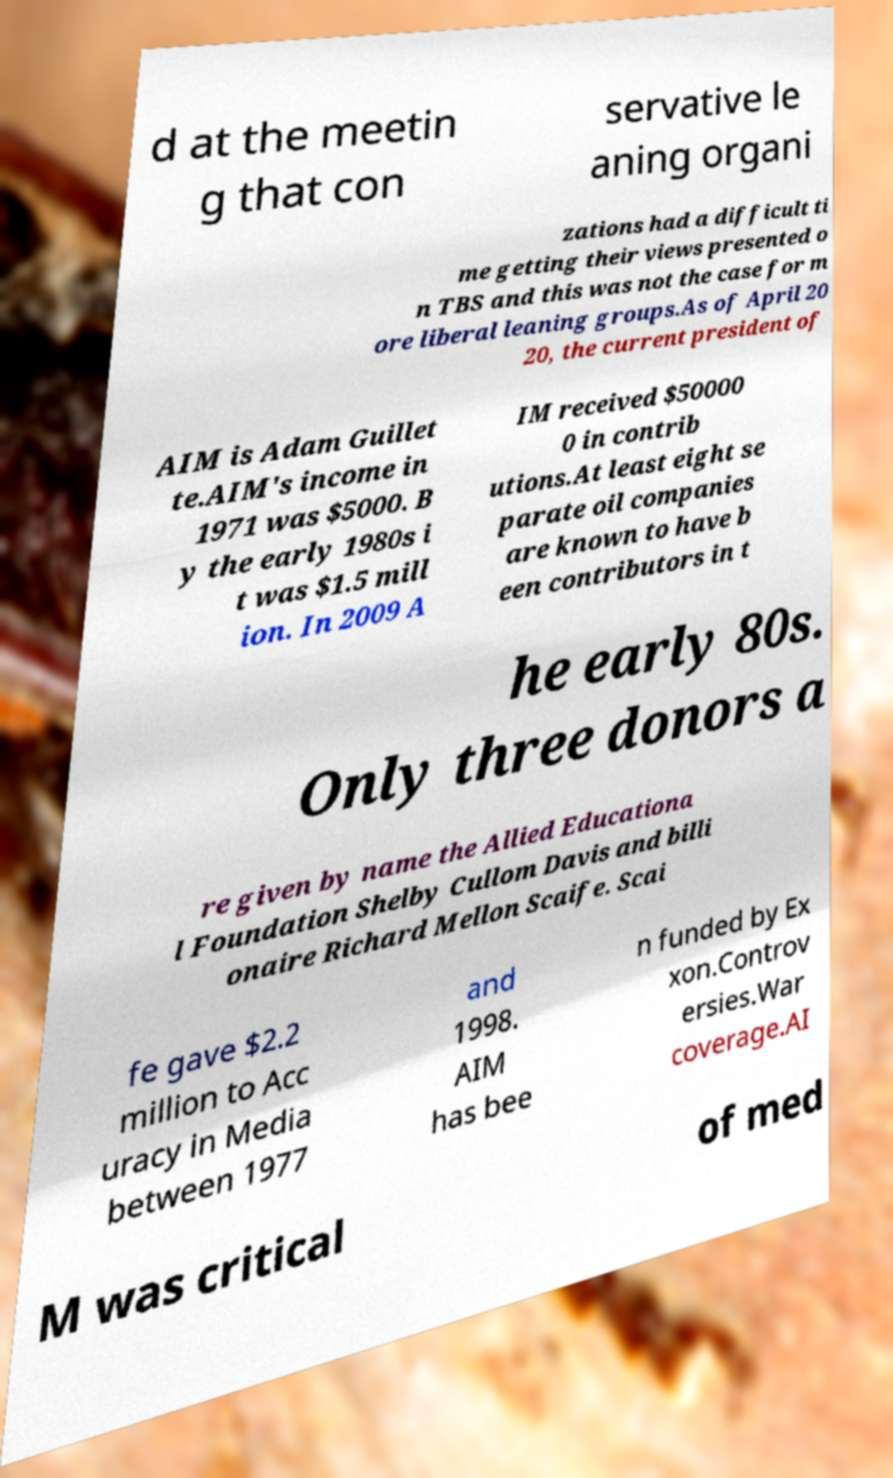There's text embedded in this image that I need extracted. Can you transcribe it verbatim? d at the meetin g that con servative le aning organi zations had a difficult ti me getting their views presented o n TBS and this was not the case for m ore liberal leaning groups.As of April 20 20, the current president of AIM is Adam Guillet te.AIM's income in 1971 was $5000. B y the early 1980s i t was $1.5 mill ion. In 2009 A IM received $50000 0 in contrib utions.At least eight se parate oil companies are known to have b een contributors in t he early 80s. Only three donors a re given by name the Allied Educationa l Foundation Shelby Cullom Davis and billi onaire Richard Mellon Scaife. Scai fe gave $2.2 million to Acc uracy in Media between 1977 and 1998. AIM has bee n funded by Ex xon.Controv ersies.War coverage.AI M was critical of med 